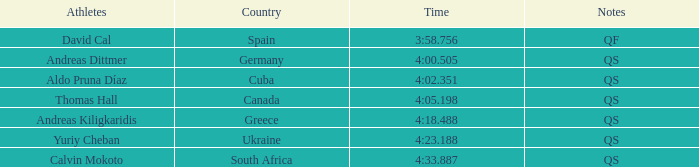What is Andreas Kiligkaridis rank? 5.0. 